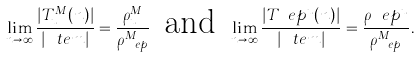Convert formula to latex. <formula><loc_0><loc_0><loc_500><loc_500>\lim _ { n \to \infty } \frac { | T _ { u } ^ { M } ( n ) | } { | \ t e m | } = \frac { \rho _ { u } ^ { M } } { \rho _ { \ e p } ^ { M } } \, \text { and } \, \lim _ { n \to \infty } \frac { | T _ { \ } e p ^ { u } ( n ) | } { | \ t e m | } = \frac { \rho _ { \ } e p ^ { u } } { \rho _ { \ e p } ^ { M } } .</formula> 